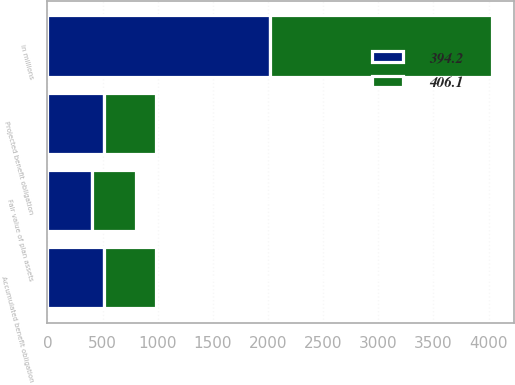Convert chart. <chart><loc_0><loc_0><loc_500><loc_500><stacked_bar_chart><ecel><fcel>in millions<fcel>Accumulated benefit obligation<fcel>Fair value of plan assets<fcel>Projected benefit obligation<nl><fcel>394.2<fcel>2014<fcel>509.9<fcel>406.1<fcel>509.9<nl><fcel>406.1<fcel>2013<fcel>473.2<fcel>394.2<fcel>473.2<nl></chart> 